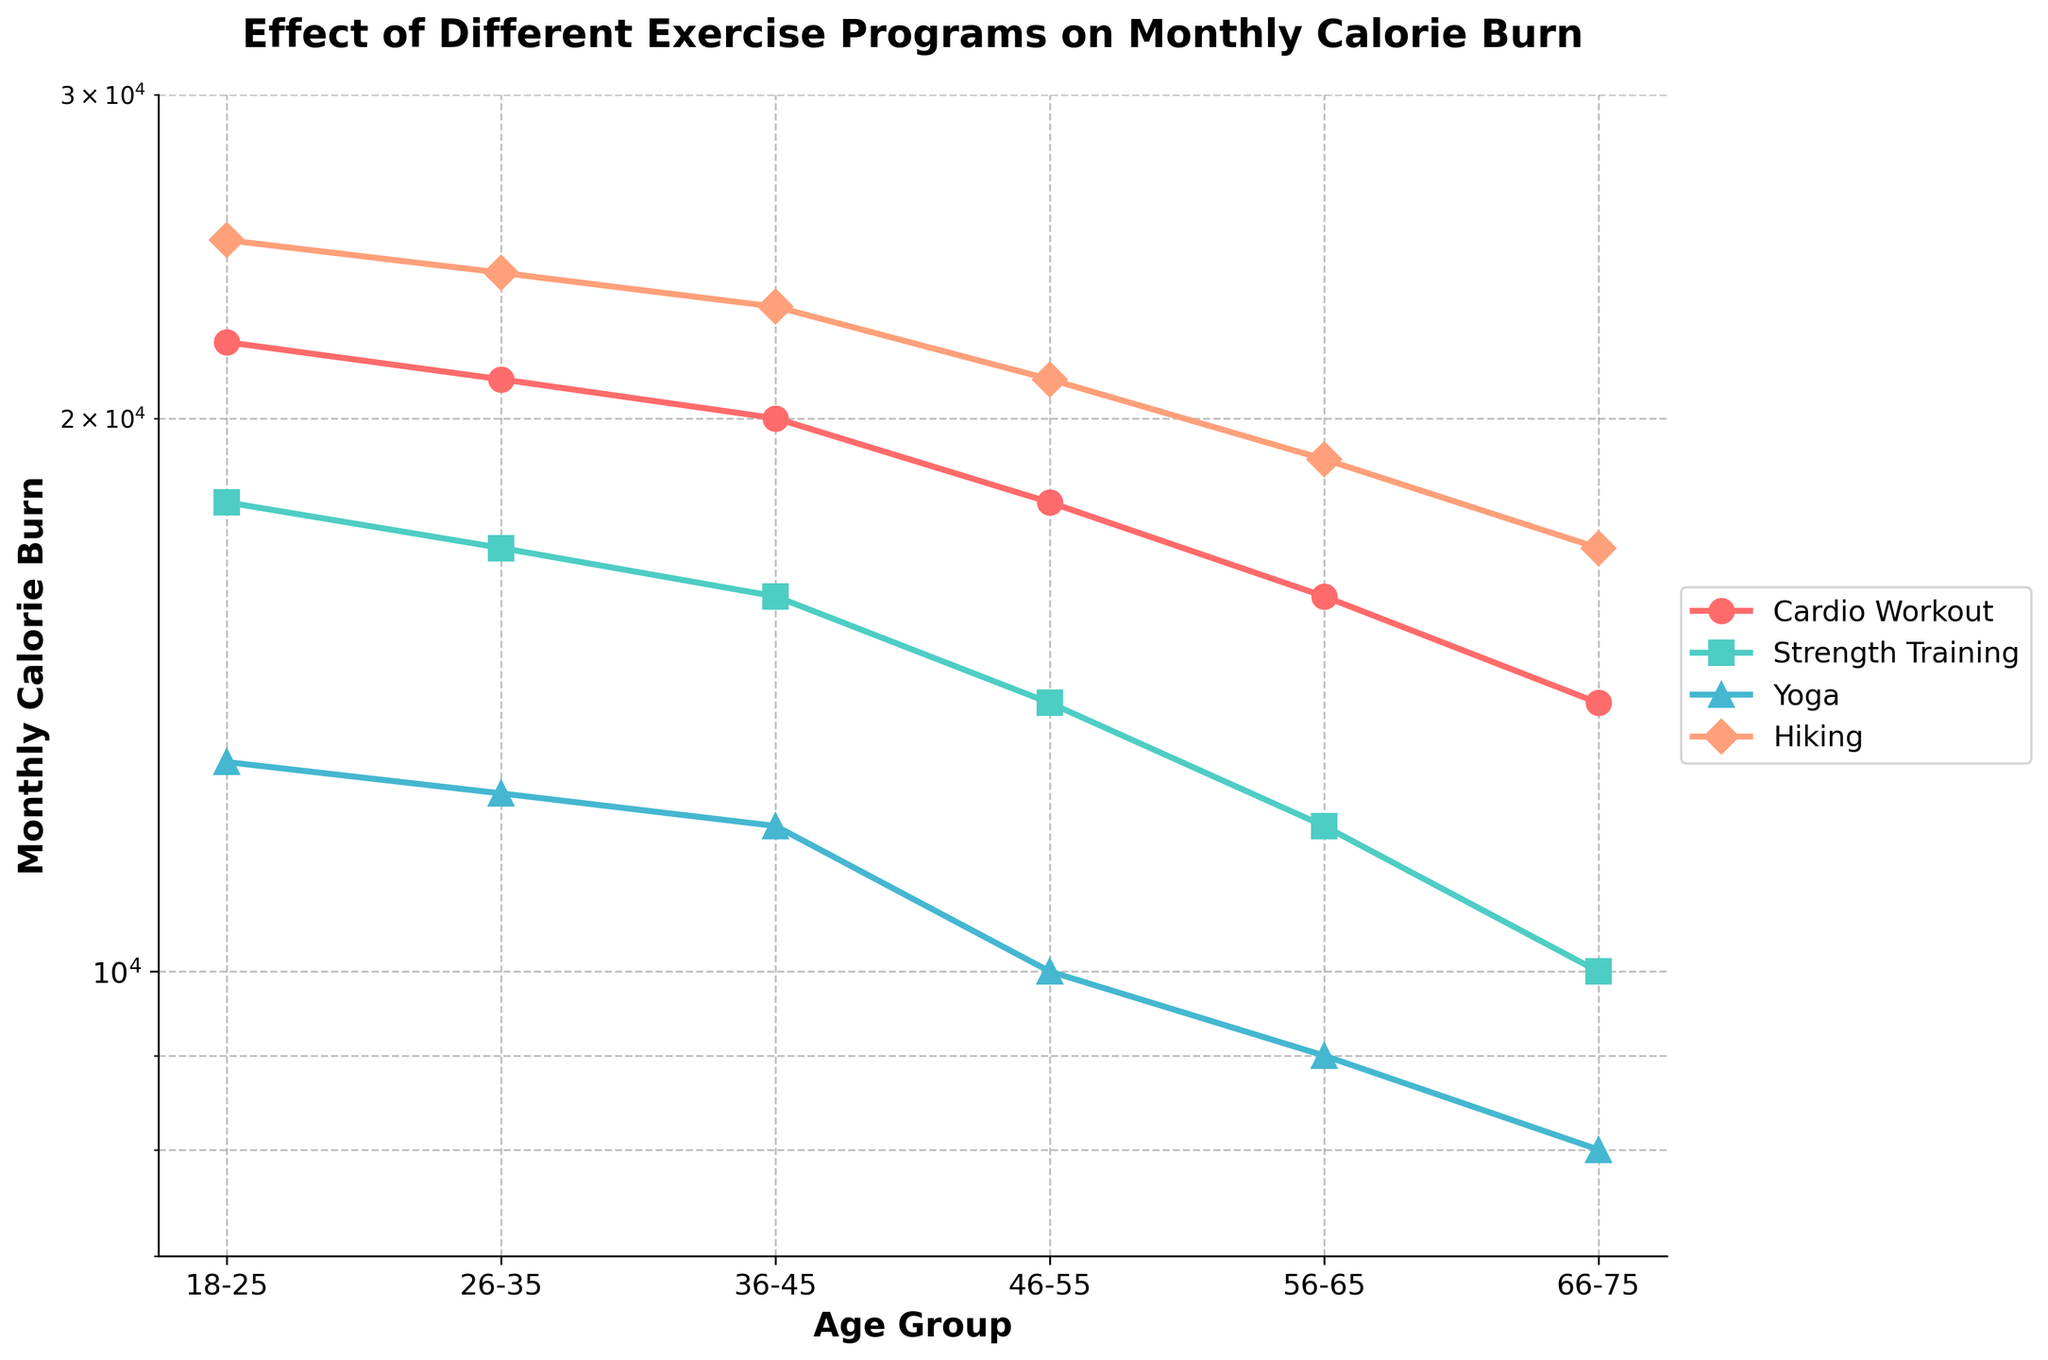what is the title of the plot? The title is located at the top center of the plot. It reads "Effect of Different Exercise Programs on Monthly Calorie Burn."
Answer: Effect of Different Exercise Programs on Monthly Calorie Burn Which exercise program leads to the highest monthly calorie burn for the 18-25 age group? Observing the lines and markers on the plot, the exercise program with the highest point in the 18-25 age group is "Hiking."
Answer: Hiking How does the calorie burn for Cardio Workout change as we move from the 36-45 age group to the 56-65 age group? Find the Cardio Workout data points for the 36-45 age group (20000) and the 56-65 age group (16000). Calculate the difference by subtracting the latter from the former. 20000 - 16000 = 4000
Answer: Decreases by 4000 Comparing Strength Training and Yoga, which one shows a greater overall decline in monthly calorie burn from 18-25 to 66-75 age groups? Calculate the difference between the calorie burns for 18-25 and 66-75 age groups for both Strength Training (18000 - 10000 = 8000) and Yoga (13000 - 8000 = 5000). 8000 > 5000
Answer: Strength Training Which age group shows the smallest difference in calorie burn between the best and worst exercise programs? Compare the differences between the highest and lowest calorie burns for each age group. The smallest difference is found in the 66-75 age group (17000 - 8000 = 9000).
Answer: 66-75 What is the monthly calorie burn for Yoga in the 46-55 age group? Find the point on the Yoga line that corresponds to the 46-55 age group. It reads a value of 10000.
Answer: 10000 In which age group does Hiking show the greatest drop in calorie burn as compared to the previous age group? Calculate the differences in Hiking calorie burns between consecutive age groups: 25000-24000=1000, 24000-23000=1000, 23000-21000=2000, 21000-19000=2000, 19000-17000=2000. The greatest drop (2000) occurs in the 46-55, 56-65, and 66-75 age groups.
Answer: 46-55, 56-65, and 66-75 If you were to recommend an exercise program for the age group 26-35 based on maximizing calorie burn, which would it be? The highest calorie burn in the 26-35 age group is shown by the Hiking line at 24000.
Answer: Hiking How many age groups are present in the plot? Count the distinct labels on the x-axis that correspond to age groups. There are six age groups represented on the plot.
Answer: Six 